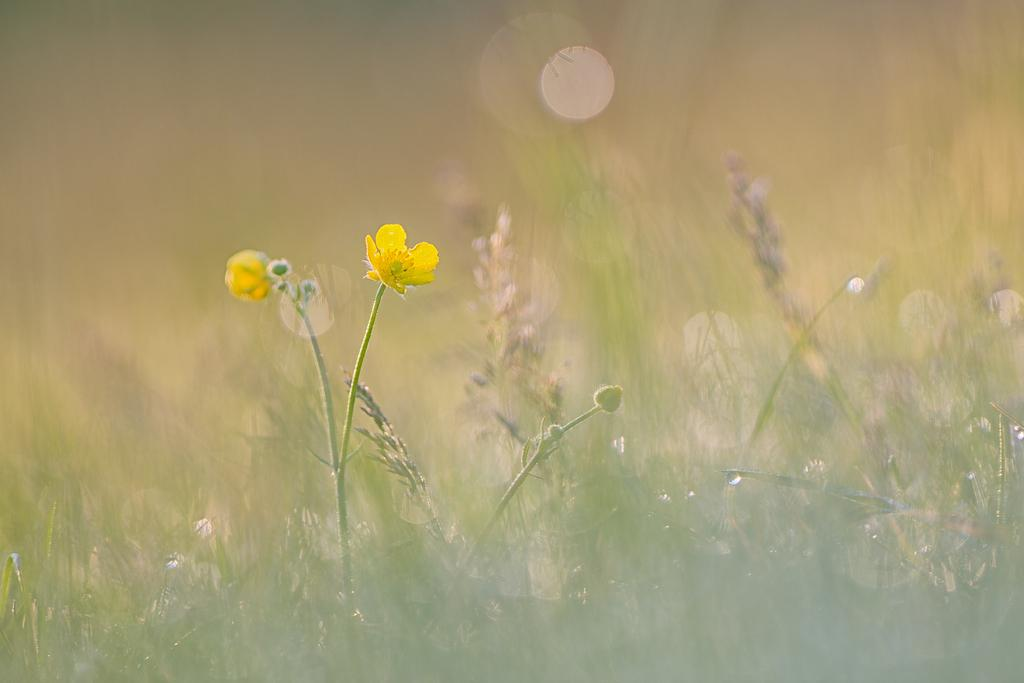What can be seen in the foreground of the image? There are flowers and plants in the foreground of the image. Can you describe the background of the image? The background of the image is blurry. What type of thread is used to hold the flowers together in the image? There is no thread visible in the image, and the flowers are not held together. 